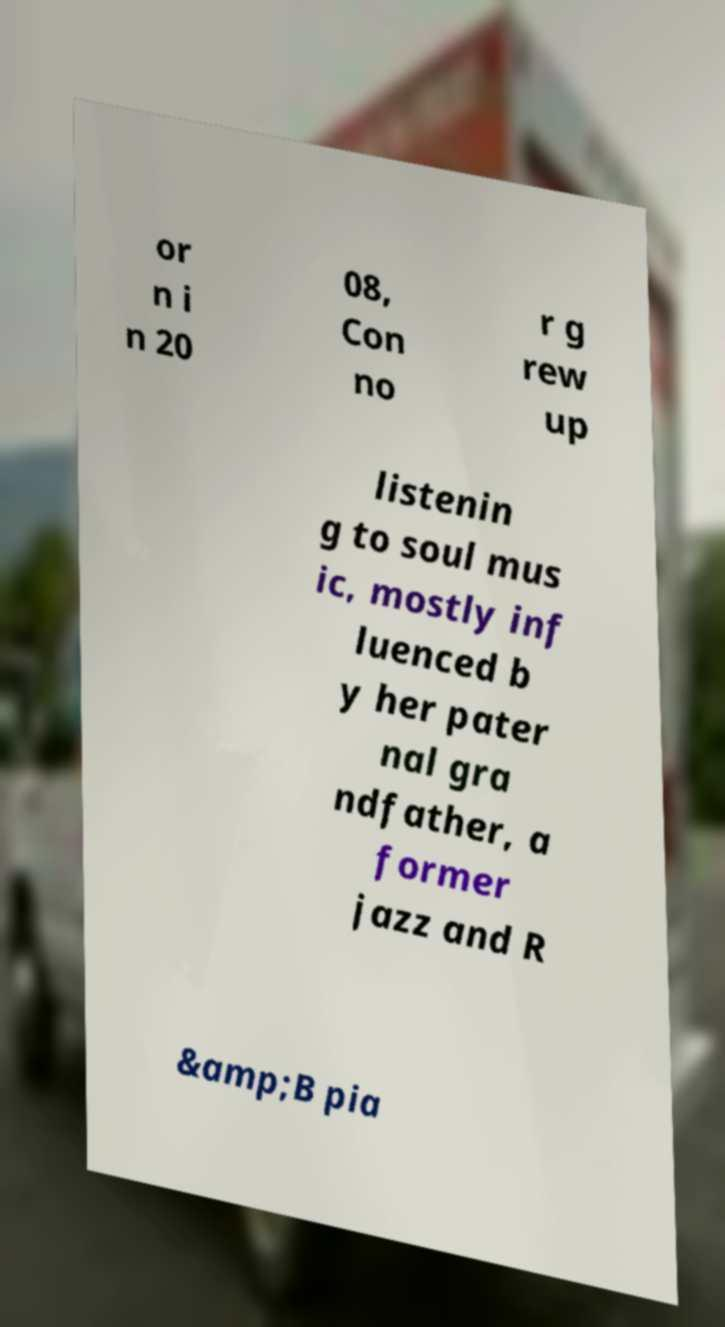Could you extract and type out the text from this image? or n i n 20 08, Con no r g rew up listenin g to soul mus ic, mostly inf luenced b y her pater nal gra ndfather, a former jazz and R &amp;B pia 